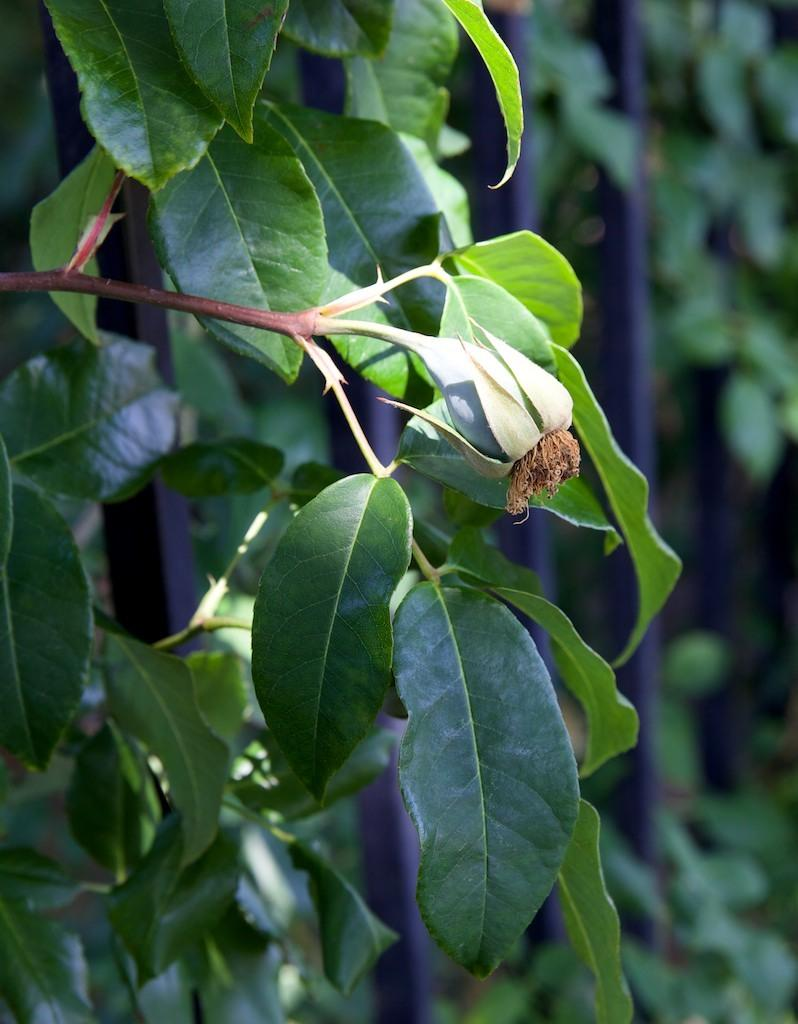What type of living organism is present in the image? There is a plant in the image. What features can be observed on the plant? The plant has leaves and a bud. What is located behind the plant in the image? There is a fence behind the plant. What else can be seen behind the fence? There are other plants visible behind the fence. What type of railway can be seen in the image? There is no railway present in the image. Can you hear a whistle in the image? There is no sound or indication of a whistle in the image. 